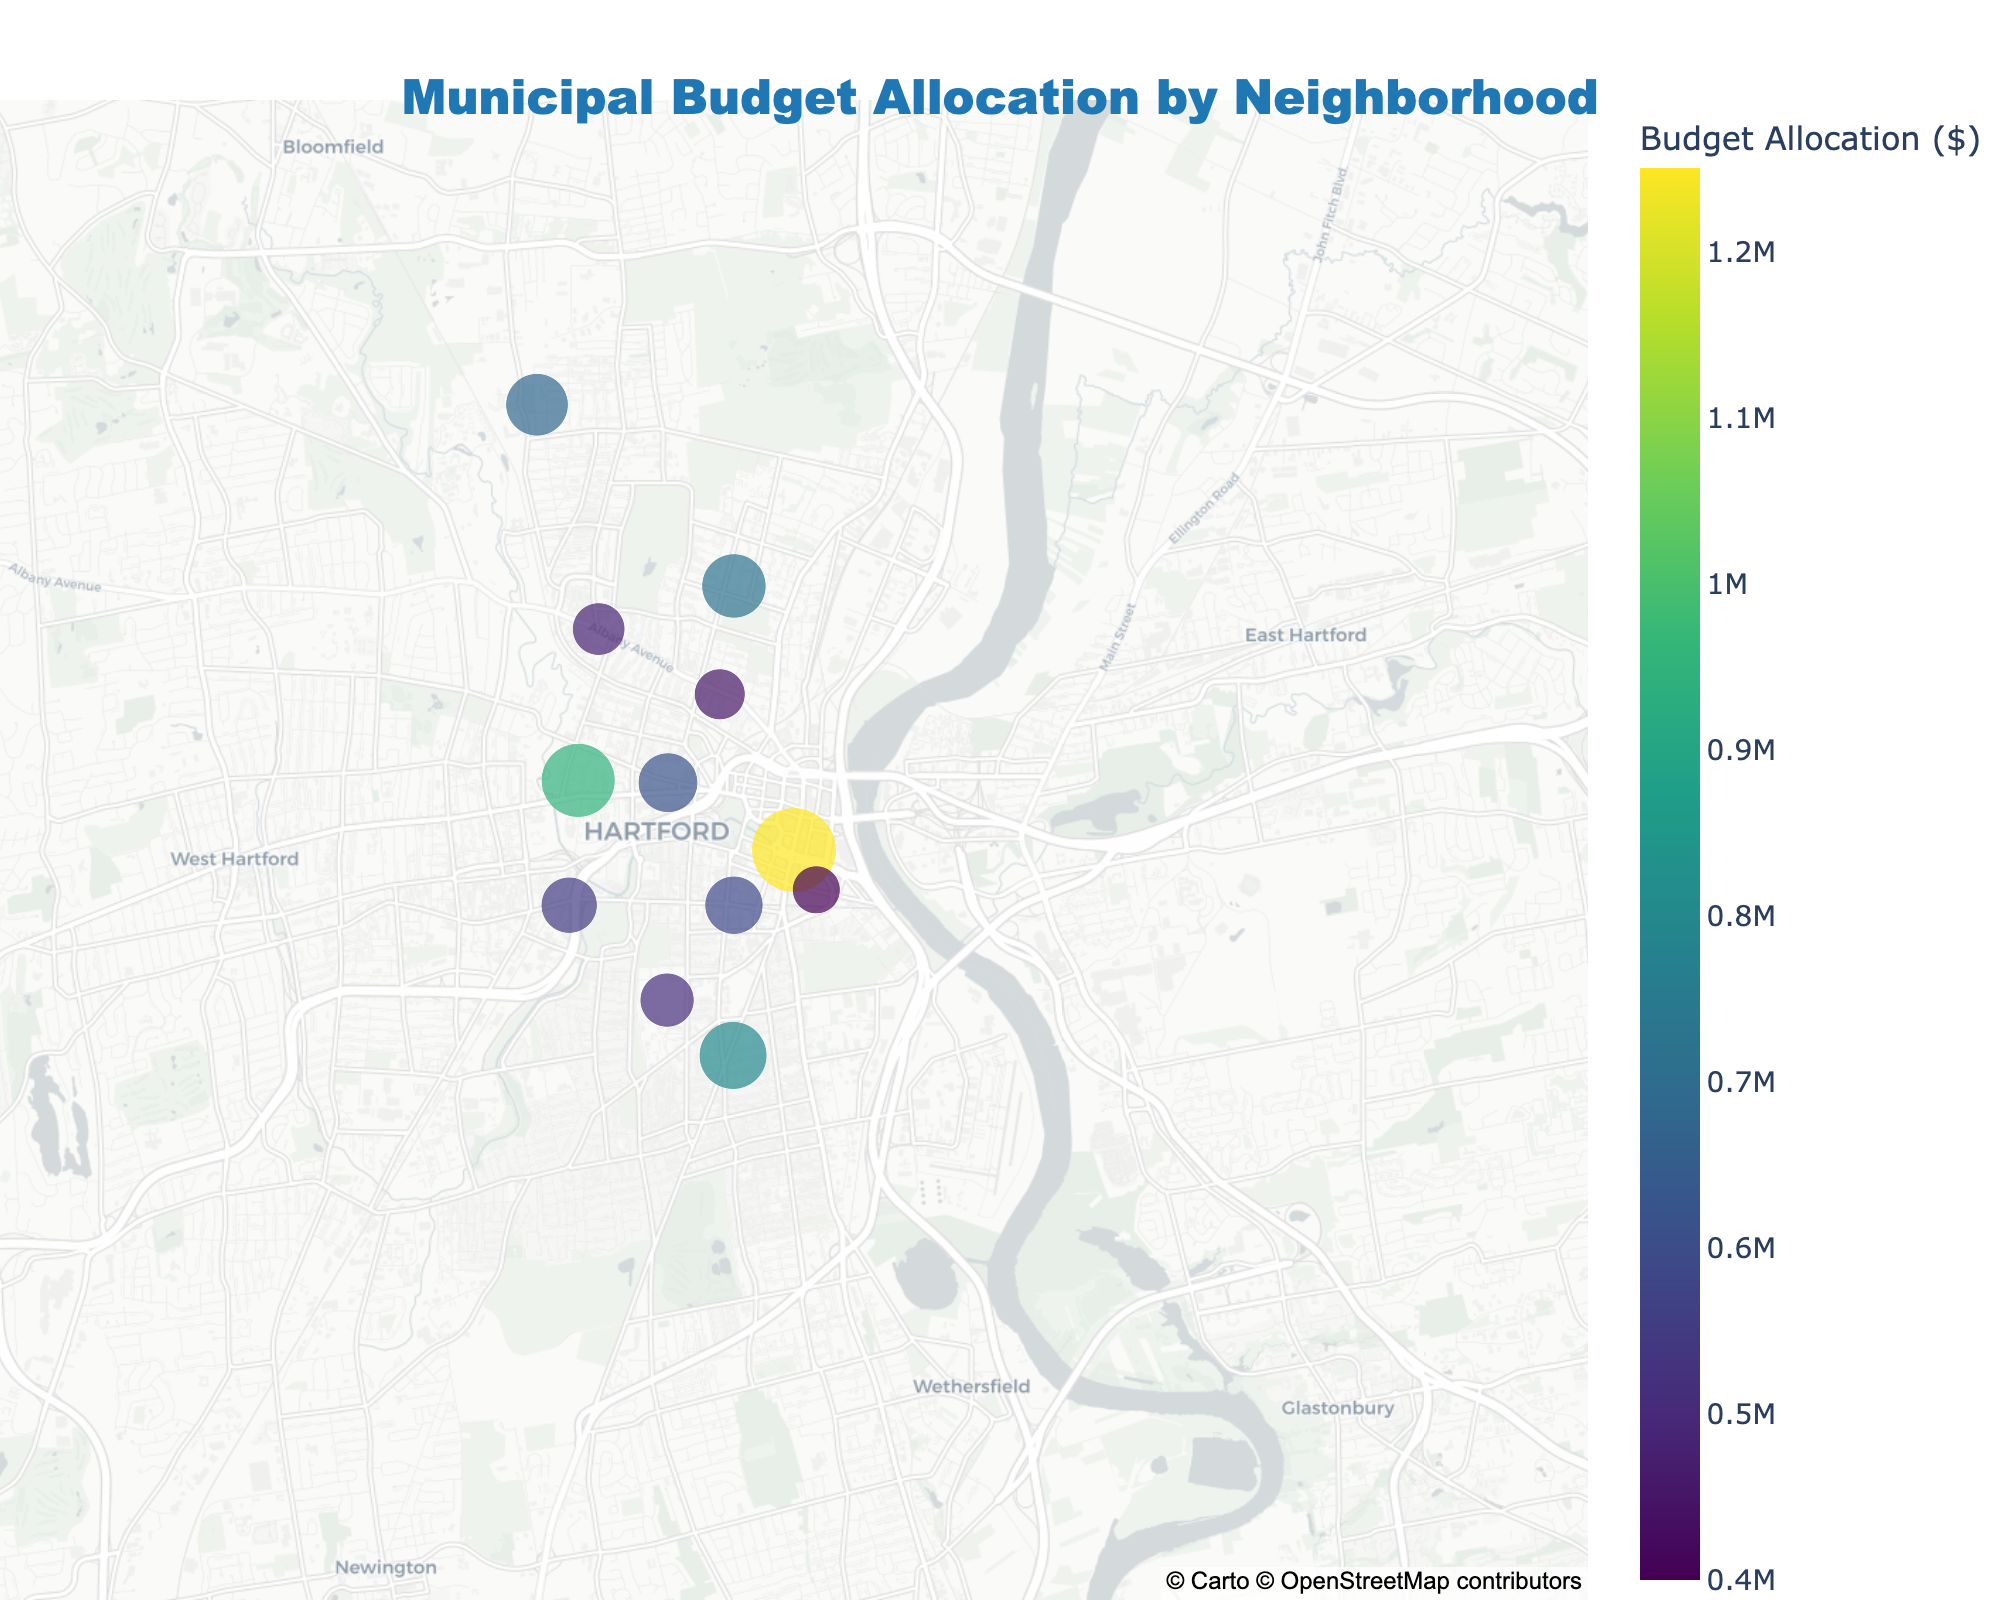What's the title of the map? The title of the map is displayed at the top center of the figure and reads: "Municipal Budget Allocation by Neighborhood".
Answer: Municipal Budget Allocation by Neighborhood Which neighborhood receives the highest budget allocation? The neighborhood with the largest circle and the deepest color on the map represents the highest budget allocation. This neighborhood is Downtown.
Answer: Downtown What's the approximate budget allocation for North End? By looking at the size and color of the circle corresponding to North End and cross-referencing the colorbar, it is evident that the budget allocation is around $720,000.
Answer: $720,000 How does the budget allocation for South End compare to Blue Hills? Compare the size and color of the circles for South End and Blue Hills. The circle for South End is slightly larger and a bit darker, indicating a higher budget allocation compared to Blue Hills.
Answer: South End has a higher budget allocation than Blue Hills What's the sum of the budget allocations for Parkville, Frog Hollow, and Barry Square? Combine the budget allocations for these three neighborhoods: Parkville ($550,000), Frog Hollow ($590,000), and Barry Square ($510,000). Thus, the total is 550,000 + 590,000 + 510,000 = 1,650,000.
Answer: $1,650,000 Which areas are geographically closer to each other: North End and Blue Hills or Parkville and Sheldon Charter Oak? By examining their positions on the map, North End and Blue Hills are located closer together in the northern part of the town, whereas Parkville is in the western area and Sheldon Charter Oak in the central part.
Answer: North End and Blue Hills What is the median budget allocation of the neighborhoods? Arrange the budget allocations in ascending order and find the middle value. The sorted values: $400,000, $450,000, $480,000, $510,000, $550,000, $590,000, $620,000, $680,000, $720,000, $800,000, $950,000, $1,250,000. The median is the average of the 6th and 7th values: (590,000 + 620,000)/2 = $605,000.
Answer: $605,000 What range of budget allocations do the color scales represent? The colorbar indicates high and low budget allocations using different intensity colors. The lowest allocation is $400,000, and the highest is $1,250,000.
Answer: $400,000 to $1,250,000 